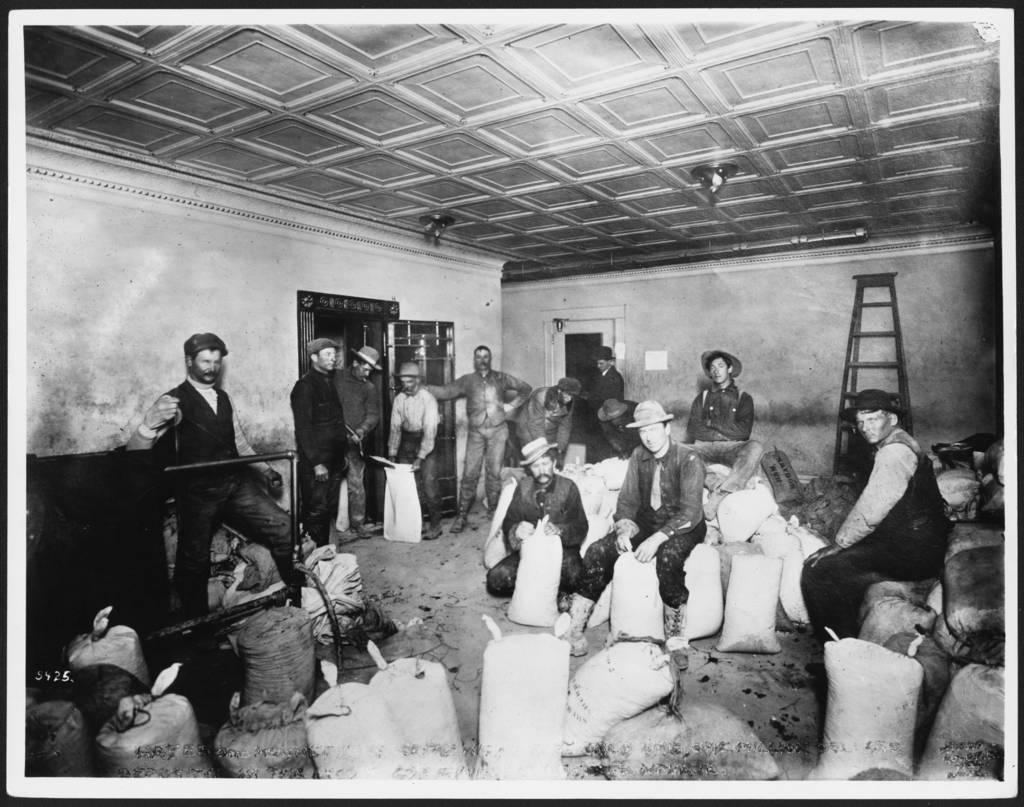Please provide a concise description of this image. In this picture we can see a room where there are many people. 